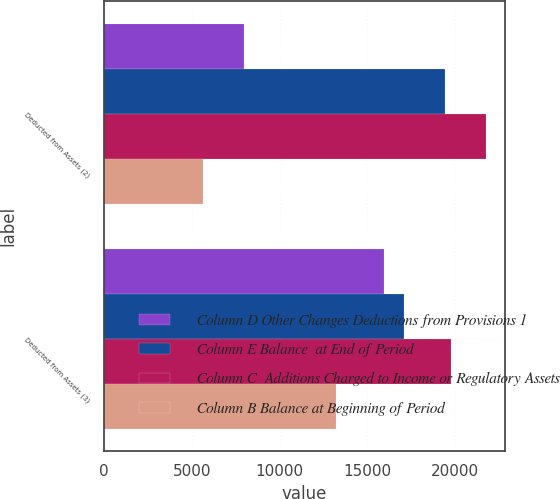Convert chart to OTSL. <chart><loc_0><loc_0><loc_500><loc_500><stacked_bar_chart><ecel><fcel>Deducted from Assets (2)<fcel>Deducted from Assets (3)<nl><fcel>Column D Other Changes Deductions from Provisions 1<fcel>7970<fcel>15925<nl><fcel>Column E Balance  at End of Period<fcel>19424<fcel>17076<nl><fcel>Column C  Additions Charged to Income or Regulatory Assets<fcel>21754<fcel>19784<nl><fcel>Column B Balance at Beginning of Period<fcel>5640<fcel>13217<nl></chart> 